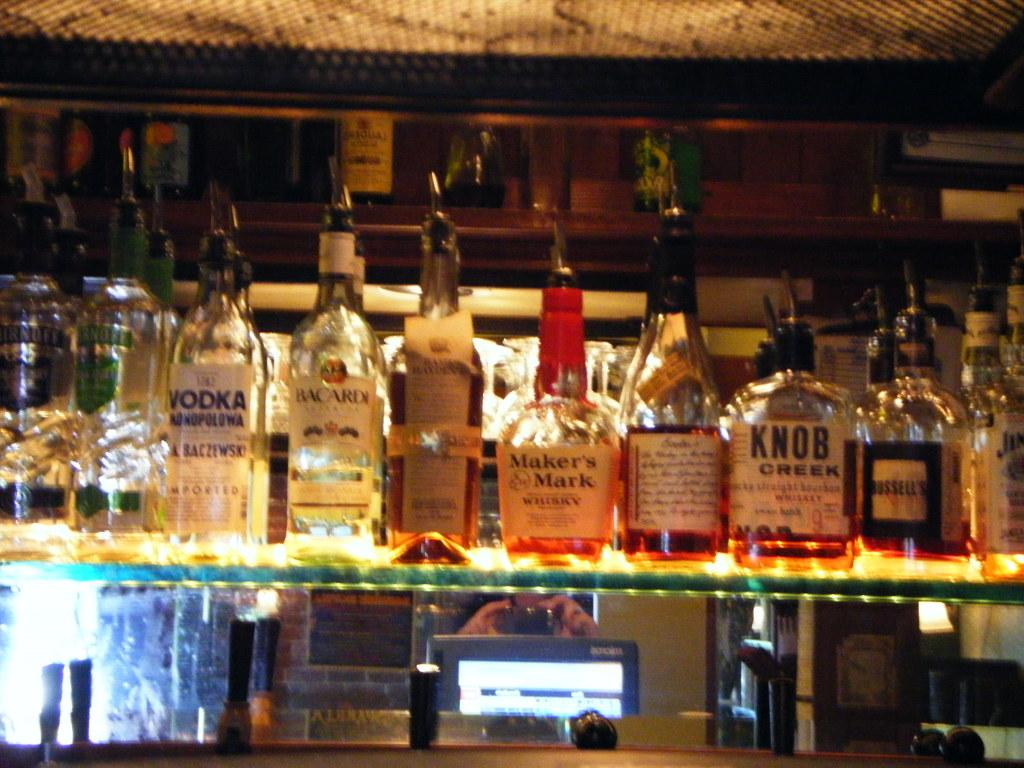Provide a one-sentence caption for the provided image. A bottle of Maker's Mark whiskey sits in the middle of other bottles on a shelf. 